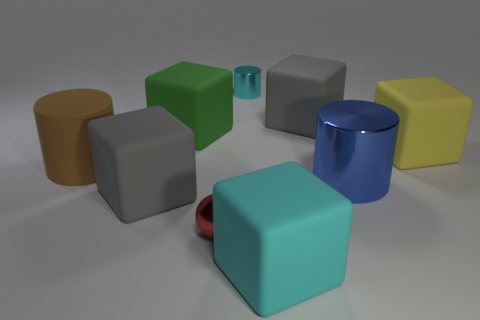Does anything in the image suggest it might be part of a larger scene or set? The arrangement of shapes and the neutral background give the impression that this could be a segment of a larger set, possibly for a graphical or educational purpose. The diversity in colors and materials hints at a designed scenario, perhaps to illustrate concepts of geometry, color theory, or materials in a visual context. 